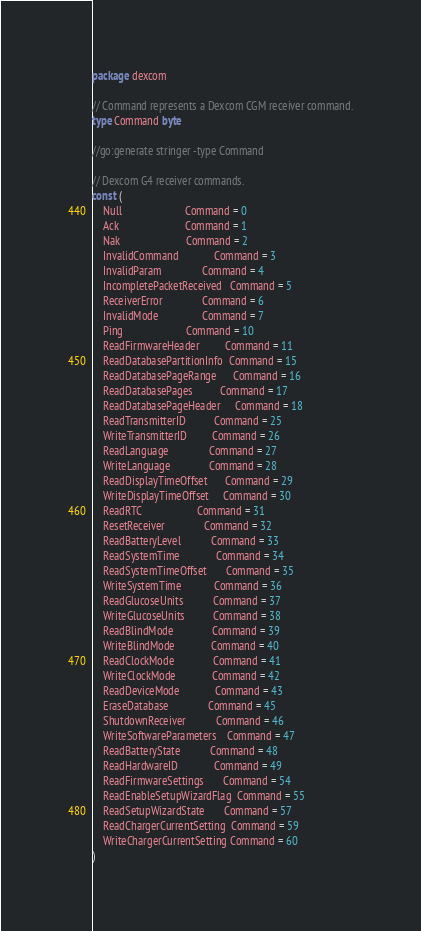Convert code to text. <code><loc_0><loc_0><loc_500><loc_500><_Go_>package dexcom

// Command represents a Dexcom CGM receiver command.
type Command byte

//go:generate stringer -type Command

// Dexcom G4 receiver commands.
const (
	Null                       Command = 0
	Ack                        Command = 1
	Nak                        Command = 2
	InvalidCommand             Command = 3
	InvalidParam               Command = 4
	IncompletePacketReceived   Command = 5
	ReceiverError              Command = 6
	InvalidMode                Command = 7
	Ping                       Command = 10
	ReadFirmwareHeader         Command = 11
	ReadDatabasePartitionInfo  Command = 15
	ReadDatabasePageRange      Command = 16
	ReadDatabasePages          Command = 17
	ReadDatabasePageHeader     Command = 18
	ReadTransmitterID          Command = 25
	WriteTransmitterID         Command = 26
	ReadLanguage               Command = 27
	WriteLanguage              Command = 28
	ReadDisplayTimeOffset      Command = 29
	WriteDisplayTimeOffset     Command = 30
	ReadRTC                    Command = 31
	ResetReceiver              Command = 32
	ReadBatteryLevel           Command = 33
	ReadSystemTime             Command = 34
	ReadSystemTimeOffset       Command = 35
	WriteSystemTime            Command = 36
	ReadGlucoseUnits           Command = 37
	WriteGlucoseUnits          Command = 38
	ReadBlindMode              Command = 39
	WriteBlindMode             Command = 40
	ReadClockMode              Command = 41
	WriteClockMode             Command = 42
	ReadDeviceMode             Command = 43
	EraseDatabase              Command = 45
	ShutdownReceiver           Command = 46
	WriteSoftwareParameters    Command = 47
	ReadBatteryState           Command = 48
	ReadHardwareID             Command = 49
	ReadFirmwareSettings       Command = 54
	ReadEnableSetupWizardFlag  Command = 55
	ReadSetupWizardState       Command = 57
	ReadChargerCurrentSetting  Command = 59
	WriteChargerCurrentSetting Command = 60
)
</code> 